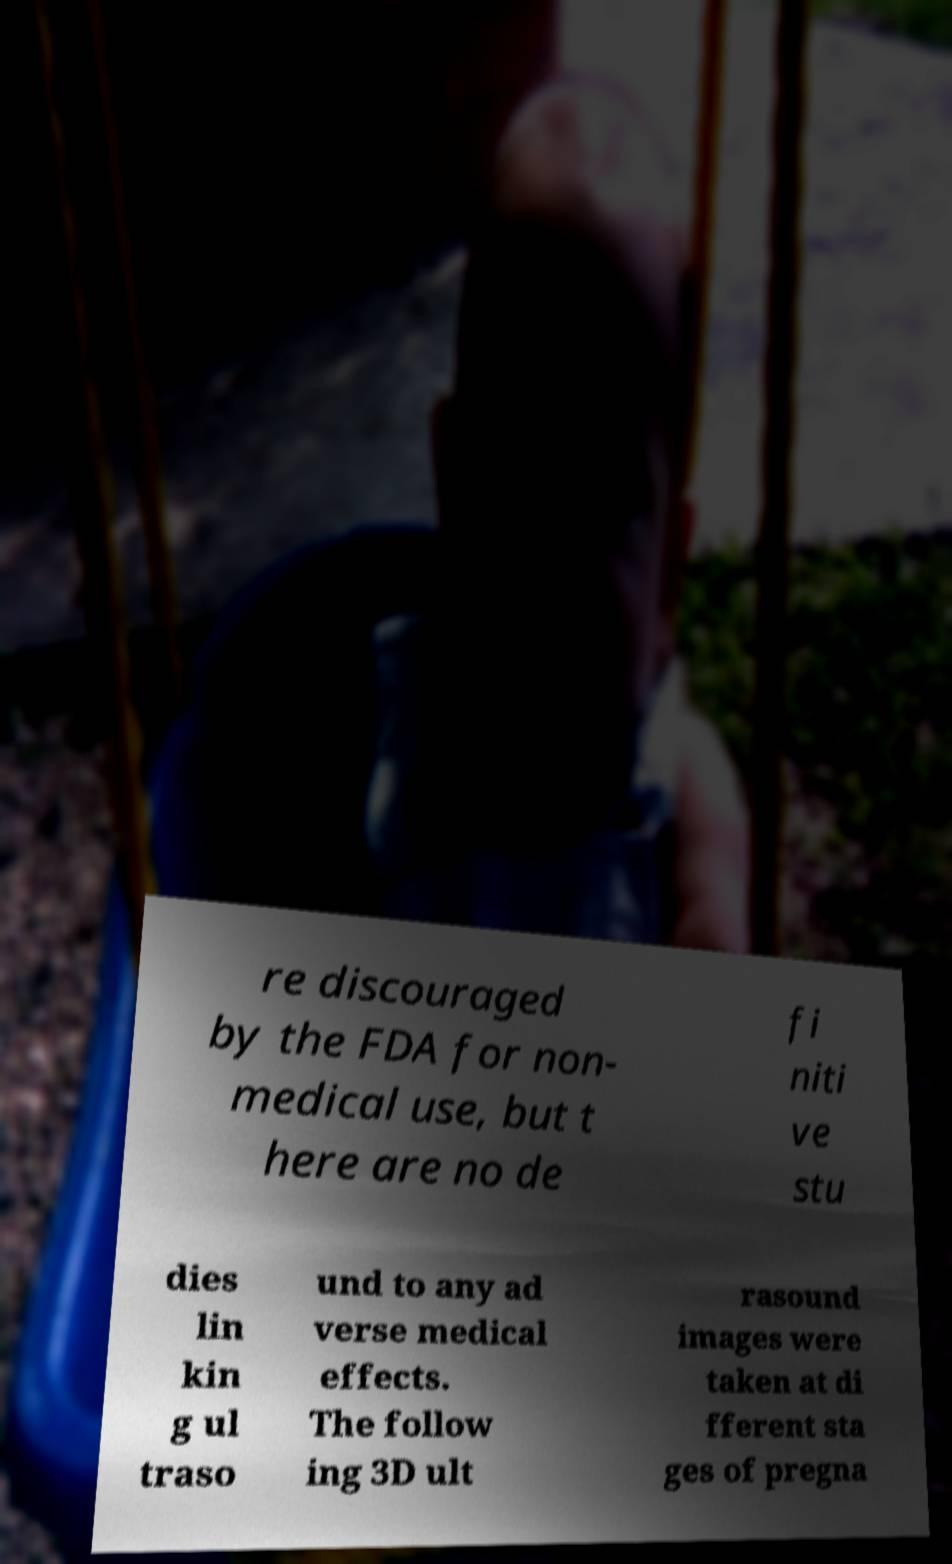Could you extract and type out the text from this image? re discouraged by the FDA for non- medical use, but t here are no de fi niti ve stu dies lin kin g ul traso und to any ad verse medical effects. The follow ing 3D ult rasound images were taken at di fferent sta ges of pregna 